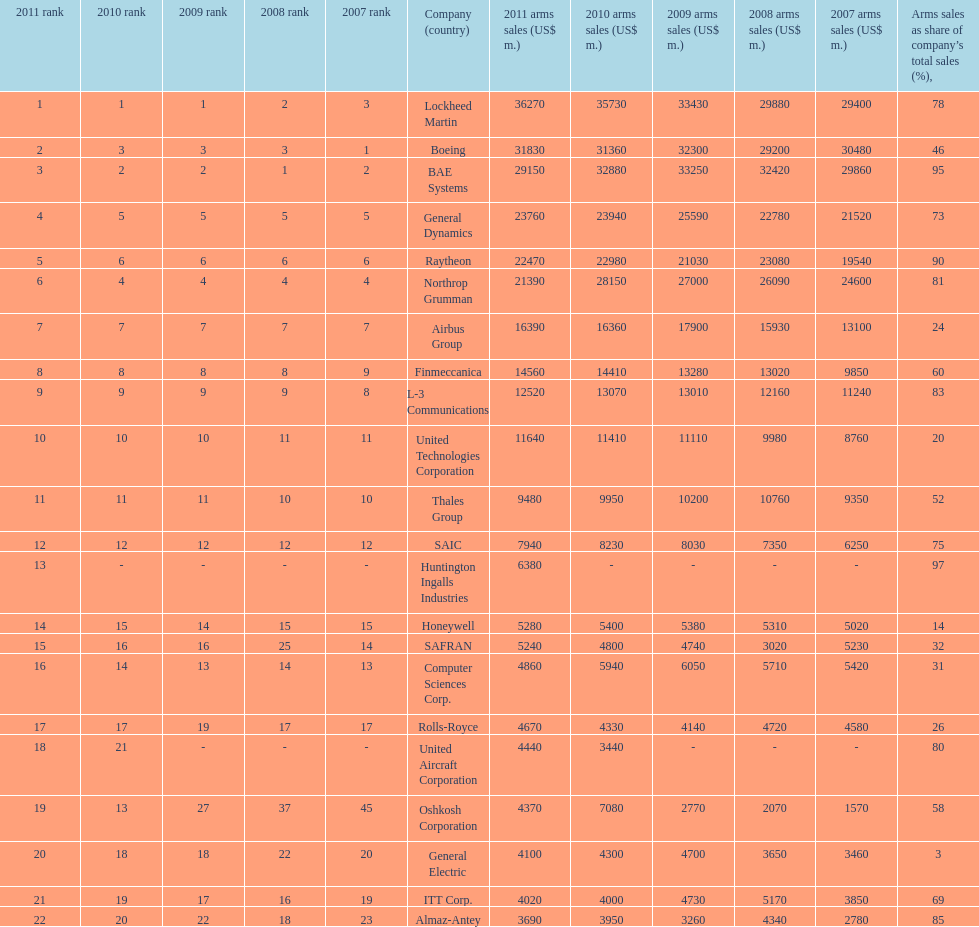How many diverse countries are recorded? 6. 